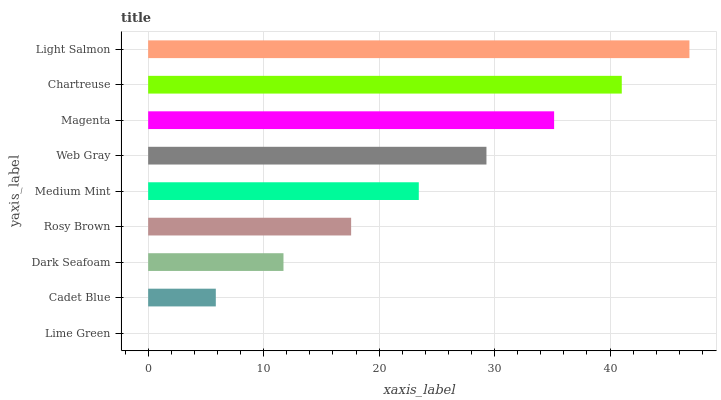Is Lime Green the minimum?
Answer yes or no. Yes. Is Light Salmon the maximum?
Answer yes or no. Yes. Is Cadet Blue the minimum?
Answer yes or no. No. Is Cadet Blue the maximum?
Answer yes or no. No. Is Cadet Blue greater than Lime Green?
Answer yes or no. Yes. Is Lime Green less than Cadet Blue?
Answer yes or no. Yes. Is Lime Green greater than Cadet Blue?
Answer yes or no. No. Is Cadet Blue less than Lime Green?
Answer yes or no. No. Is Medium Mint the high median?
Answer yes or no. Yes. Is Medium Mint the low median?
Answer yes or no. Yes. Is Dark Seafoam the high median?
Answer yes or no. No. Is Chartreuse the low median?
Answer yes or no. No. 